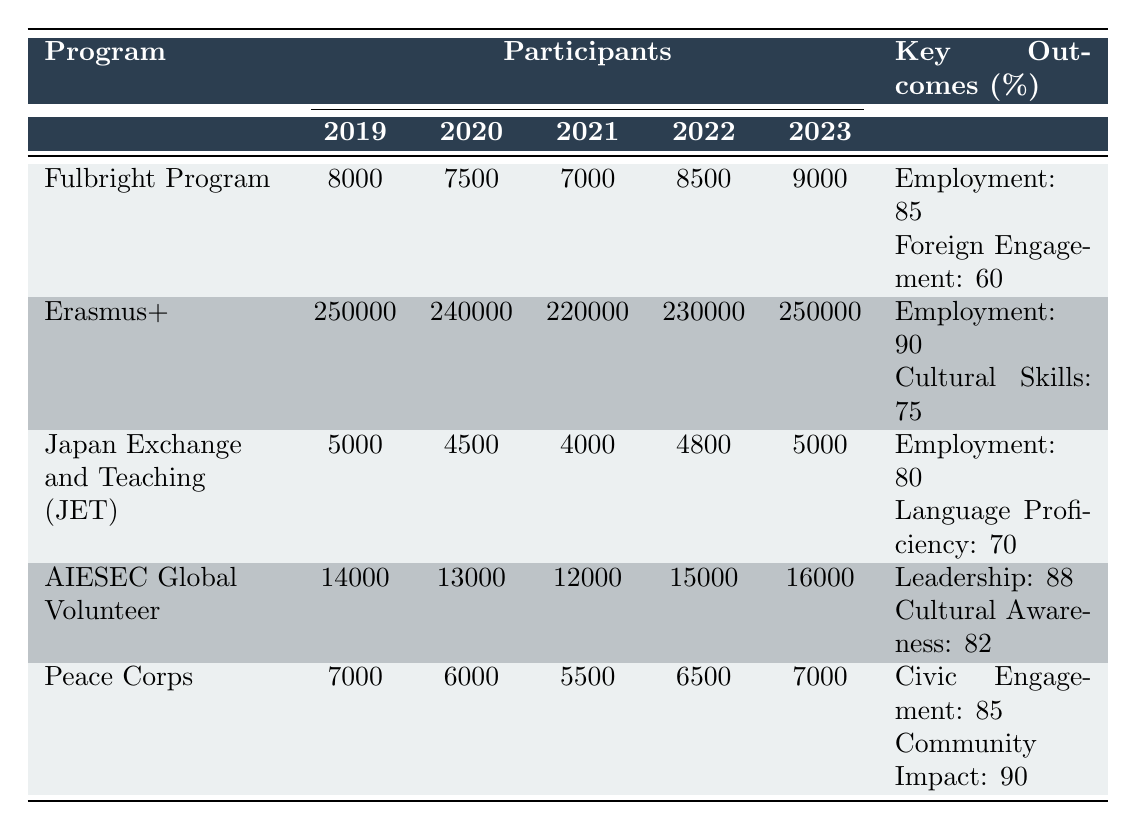What was the highest number of participants in the Erasmus+ program during this period? The table shows the number of participants in the Erasmus+ program for each year from 2019 to 2023. The highest number is found in 2019 with 250000 participants.
Answer: 250000 What was the total participant count for the Fulbright Program over the years 2019 to 2023? To find the total, sum the participants: 8000 + 7500 + 7000 + 8500 + 9000 = 39900.
Answer: 39900 Did the number of participants in the Japan Exchange and Teaching (JET) Program increase from 2021 to 2022? Comparing the numbers, 2021 has 4000 participants and 2022 has 4800 participants. Since 4800 is greater than 4000, the number did increase.
Answer: Yes Which program had the lowest employment rate? Looking at the outcomes for each program, the Fulbright Program has an employment rate of 85%, while the JET Program has 80%. The JET Program has the lowest employment rate in the table.
Answer: Japan Exchange and Teaching (JET) Program What was the average number of participants in the AIESEC Global Volunteer program over the years? To calculate the average, sum the participants: 14000 + 13000 + 12000 + 15000 + 16000 = 70000, and divide by 5 (the number of years), resulting in 70000/5 = 14000.
Answer: 14000 How many more participants were in the Peace Corps in 2022 compared to 2021? The Peace Corps had 6500 participants in 2022 and 5500 in 2021. Subtracting these gives 6500 - 5500 = 1000, showing an increase of 1000 participants.
Answer: 1000 Is it true that the AIESEC Global Volunteer program had a higher cultural awareness outcome than the Fulbright Program's continued engagement outcome? AIESEC's cultural awareness is 82%, while the Fulbright's continued engagement is 60%. Since 82% is greater than 60%, the statement is true.
Answer: Yes Which program maintained a fairly consistent number of participants over the years? The Peace Corps shows a gradual decline and then stabilization with values of 7000, 6000, 5500, 6500, and returning to 7000 in 2023, indicating it maintained a stable participant count relative to others.
Answer: Peace Corps 